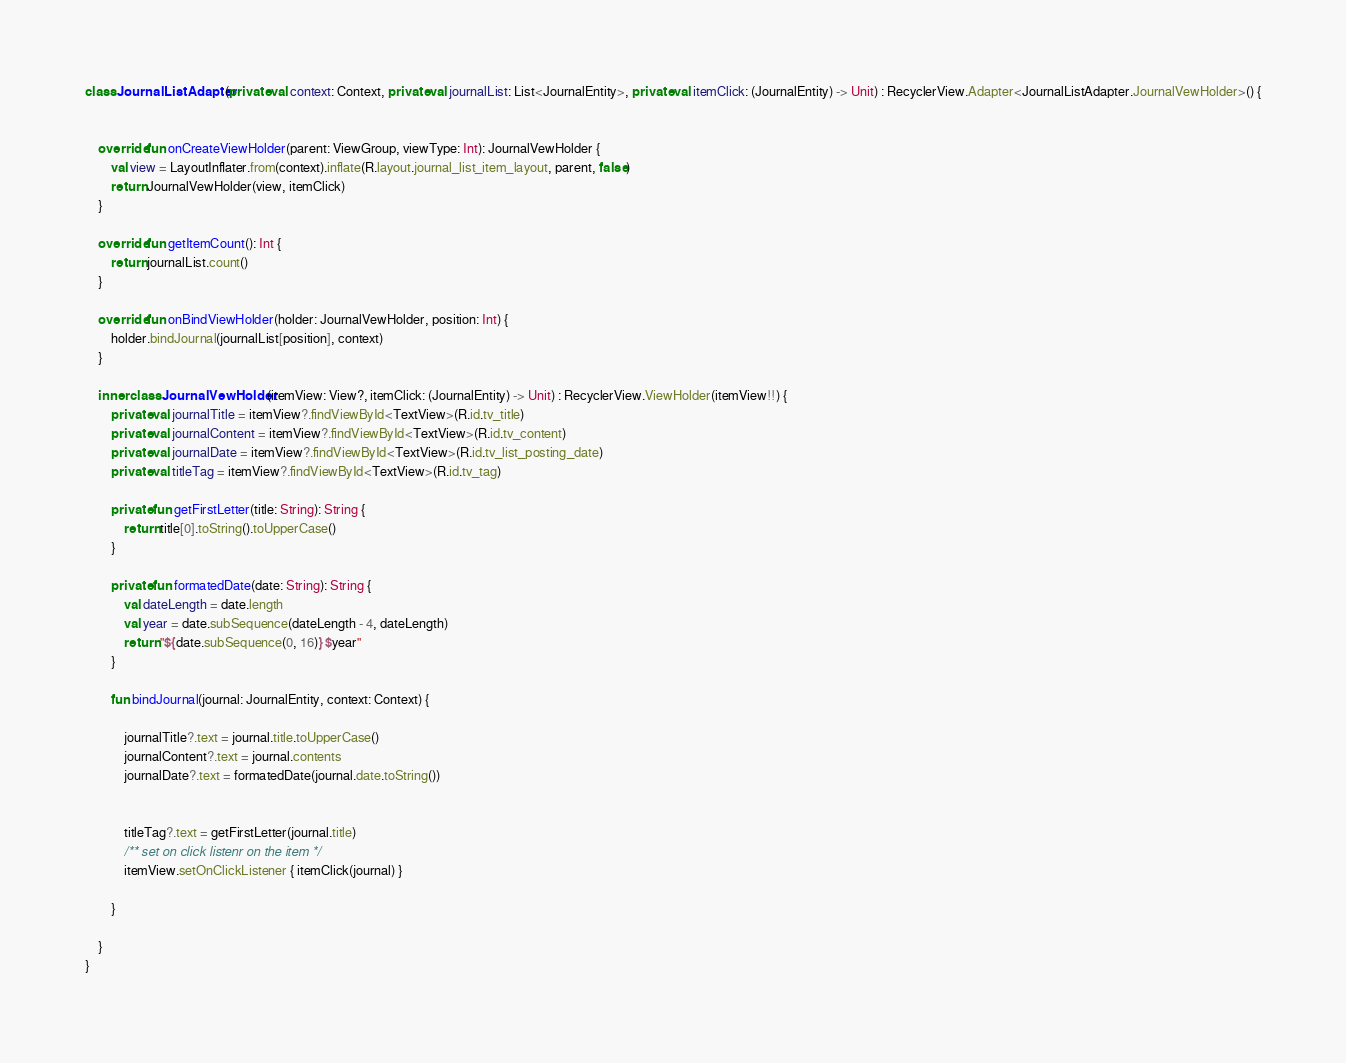<code> <loc_0><loc_0><loc_500><loc_500><_Kotlin_>class JournalListAdapter(private val context: Context, private val journalList: List<JournalEntity>, private val itemClick: (JournalEntity) -> Unit) : RecyclerView.Adapter<JournalListAdapter.JournalVewHolder>() {


    override fun onCreateViewHolder(parent: ViewGroup, viewType: Int): JournalVewHolder {
        val view = LayoutInflater.from(context).inflate(R.layout.journal_list_item_layout, parent, false)
        return JournalVewHolder(view, itemClick)
    }

    override fun getItemCount(): Int {
        return journalList.count()
    }

    override fun onBindViewHolder(holder: JournalVewHolder, position: Int) {
        holder.bindJournal(journalList[position], context)
    }

    inner class JournalVewHolder(itemView: View?, itemClick: (JournalEntity) -> Unit) : RecyclerView.ViewHolder(itemView!!) {
        private val journalTitle = itemView?.findViewById<TextView>(R.id.tv_title)
        private val journalContent = itemView?.findViewById<TextView>(R.id.tv_content)
        private val journalDate = itemView?.findViewById<TextView>(R.id.tv_list_posting_date)
        private val titleTag = itemView?.findViewById<TextView>(R.id.tv_tag)

        private fun getFirstLetter(title: String): String {
            return title[0].toString().toUpperCase()
        }

        private fun formatedDate(date: String): String {
            val dateLength = date.length
            val year = date.subSequence(dateLength - 4, dateLength)
            return "${date.subSequence(0, 16)} $year"
        }

        fun bindJournal(journal: JournalEntity, context: Context) {

            journalTitle?.text = journal.title.toUpperCase()
            journalContent?.text = journal.contents
            journalDate?.text = formatedDate(journal.date.toString())


            titleTag?.text = getFirstLetter(journal.title)
            /** set on click listenr on the item */
            itemView.setOnClickListener { itemClick(journal) }

        }

    }
}</code> 